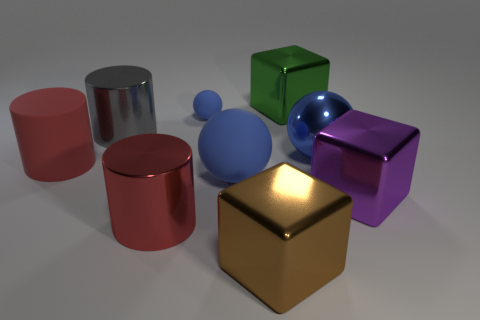How many blue balls must be subtracted to get 1 blue balls? 2 Add 1 yellow cylinders. How many objects exist? 10 Subtract all purple cubes. How many cubes are left? 2 Subtract all green balls. How many red cylinders are left? 2 Subtract all cubes. How many objects are left? 6 Subtract all large blue metallic spheres. Subtract all small rubber objects. How many objects are left? 7 Add 1 blue things. How many blue things are left? 4 Add 2 gray metal things. How many gray metal things exist? 3 Subtract 1 green blocks. How many objects are left? 8 Subtract all red cylinders. Subtract all brown balls. How many cylinders are left? 1 